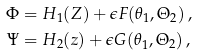Convert formula to latex. <formula><loc_0><loc_0><loc_500><loc_500>\Phi & = H _ { 1 } ( Z ) + \epsilon F ( \theta _ { 1 } , \Theta _ { 2 } ) \, , \\ \Psi & = H _ { 2 } ( z ) + \epsilon G ( \theta _ { 1 } , \Theta _ { 2 } ) \, ,</formula> 